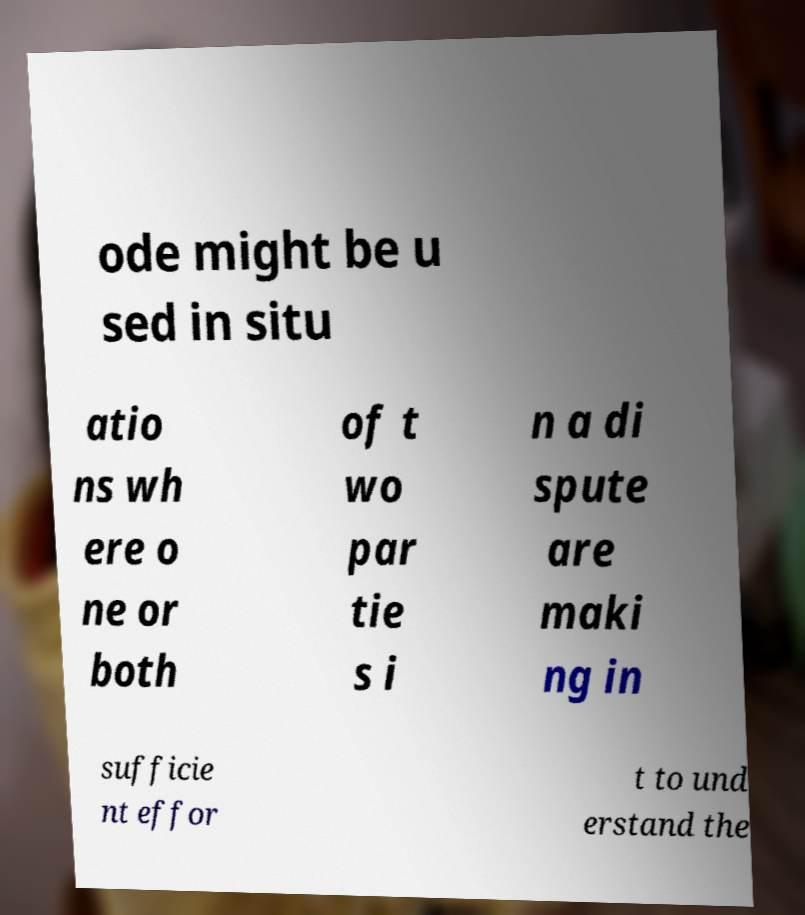There's text embedded in this image that I need extracted. Can you transcribe it verbatim? ode might be u sed in situ atio ns wh ere o ne or both of t wo par tie s i n a di spute are maki ng in sufficie nt effor t to und erstand the 